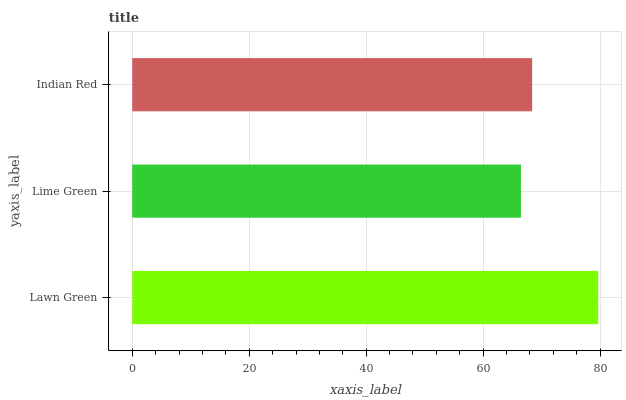Is Lime Green the minimum?
Answer yes or no. Yes. Is Lawn Green the maximum?
Answer yes or no. Yes. Is Indian Red the minimum?
Answer yes or no. No. Is Indian Red the maximum?
Answer yes or no. No. Is Indian Red greater than Lime Green?
Answer yes or no. Yes. Is Lime Green less than Indian Red?
Answer yes or no. Yes. Is Lime Green greater than Indian Red?
Answer yes or no. No. Is Indian Red less than Lime Green?
Answer yes or no. No. Is Indian Red the high median?
Answer yes or no. Yes. Is Indian Red the low median?
Answer yes or no. Yes. Is Lime Green the high median?
Answer yes or no. No. Is Lawn Green the low median?
Answer yes or no. No. 